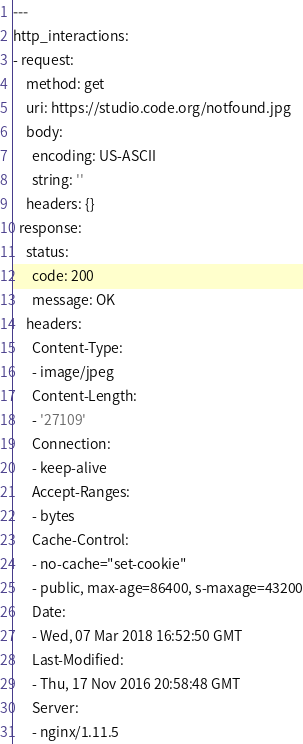<code> <loc_0><loc_0><loc_500><loc_500><_YAML_>---
http_interactions:
- request:
    method: get
    uri: https://studio.code.org/notfound.jpg
    body:
      encoding: US-ASCII
      string: ''
    headers: {}
  response:
    status:
      code: 200
      message: OK
    headers:
      Content-Type:
      - image/jpeg
      Content-Length:
      - '27109'
      Connection:
      - keep-alive
      Accept-Ranges:
      - bytes
      Cache-Control:
      - no-cache="set-cookie"
      - public, max-age=86400, s-maxage=43200
      Date:
      - Wed, 07 Mar 2018 16:52:50 GMT
      Last-Modified:
      - Thu, 17 Nov 2016 20:58:48 GMT
      Server:
      - nginx/1.11.5</code> 